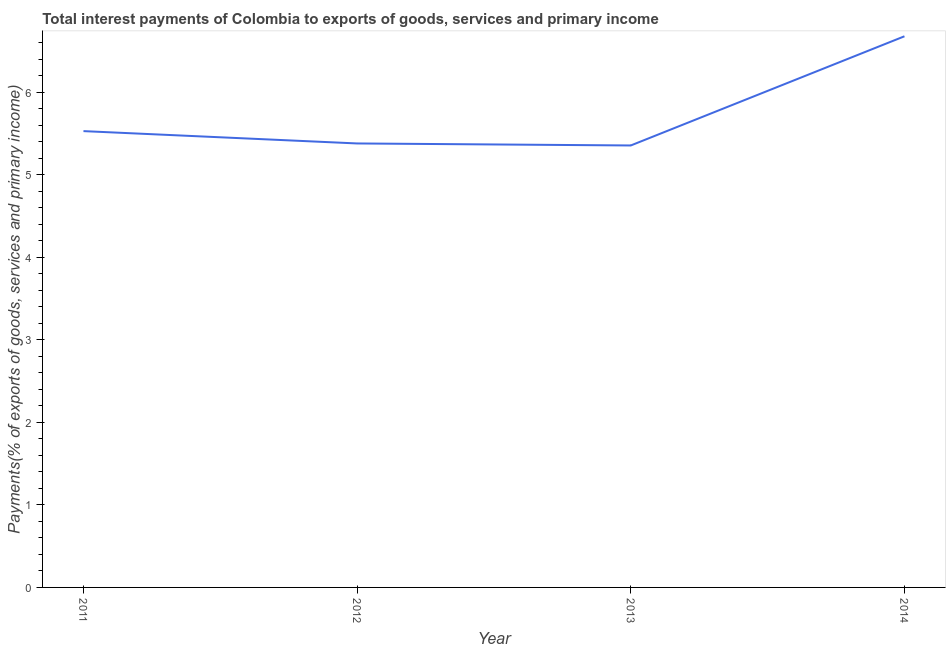What is the total interest payments on external debt in 2014?
Make the answer very short. 6.68. Across all years, what is the maximum total interest payments on external debt?
Your answer should be very brief. 6.68. Across all years, what is the minimum total interest payments on external debt?
Ensure brevity in your answer.  5.36. In which year was the total interest payments on external debt maximum?
Give a very brief answer. 2014. In which year was the total interest payments on external debt minimum?
Provide a succinct answer. 2013. What is the sum of the total interest payments on external debt?
Offer a terse response. 22.94. What is the difference between the total interest payments on external debt in 2012 and 2013?
Provide a succinct answer. 0.02. What is the average total interest payments on external debt per year?
Offer a very short reply. 5.74. What is the median total interest payments on external debt?
Your answer should be very brief. 5.46. What is the ratio of the total interest payments on external debt in 2012 to that in 2014?
Provide a short and direct response. 0.81. Is the total interest payments on external debt in 2013 less than that in 2014?
Your answer should be compact. Yes. Is the difference between the total interest payments on external debt in 2011 and 2014 greater than the difference between any two years?
Make the answer very short. No. What is the difference between the highest and the second highest total interest payments on external debt?
Provide a short and direct response. 1.15. What is the difference between the highest and the lowest total interest payments on external debt?
Make the answer very short. 1.32. How many lines are there?
Provide a succinct answer. 1. How many years are there in the graph?
Provide a short and direct response. 4. Does the graph contain grids?
Your response must be concise. No. What is the title of the graph?
Keep it short and to the point. Total interest payments of Colombia to exports of goods, services and primary income. What is the label or title of the X-axis?
Offer a terse response. Year. What is the label or title of the Y-axis?
Keep it short and to the point. Payments(% of exports of goods, services and primary income). What is the Payments(% of exports of goods, services and primary income) in 2011?
Offer a terse response. 5.53. What is the Payments(% of exports of goods, services and primary income) of 2012?
Provide a short and direct response. 5.38. What is the Payments(% of exports of goods, services and primary income) in 2013?
Your answer should be very brief. 5.36. What is the Payments(% of exports of goods, services and primary income) in 2014?
Your answer should be compact. 6.68. What is the difference between the Payments(% of exports of goods, services and primary income) in 2011 and 2012?
Provide a succinct answer. 0.15. What is the difference between the Payments(% of exports of goods, services and primary income) in 2011 and 2013?
Your answer should be compact. 0.17. What is the difference between the Payments(% of exports of goods, services and primary income) in 2011 and 2014?
Offer a very short reply. -1.15. What is the difference between the Payments(% of exports of goods, services and primary income) in 2012 and 2013?
Offer a terse response. 0.02. What is the difference between the Payments(% of exports of goods, services and primary income) in 2012 and 2014?
Provide a succinct answer. -1.3. What is the difference between the Payments(% of exports of goods, services and primary income) in 2013 and 2014?
Provide a succinct answer. -1.32. What is the ratio of the Payments(% of exports of goods, services and primary income) in 2011 to that in 2012?
Your response must be concise. 1.03. What is the ratio of the Payments(% of exports of goods, services and primary income) in 2011 to that in 2013?
Provide a succinct answer. 1.03. What is the ratio of the Payments(% of exports of goods, services and primary income) in 2011 to that in 2014?
Offer a terse response. 0.83. What is the ratio of the Payments(% of exports of goods, services and primary income) in 2012 to that in 2013?
Make the answer very short. 1. What is the ratio of the Payments(% of exports of goods, services and primary income) in 2012 to that in 2014?
Make the answer very short. 0.81. What is the ratio of the Payments(% of exports of goods, services and primary income) in 2013 to that in 2014?
Provide a succinct answer. 0.8. 